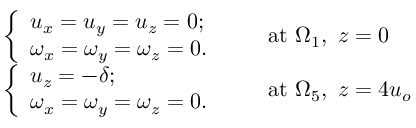<formula> <loc_0><loc_0><loc_500><loc_500>\begin{array} { r l } & { \left \{ \begin{array} { l l } { u _ { x } = u _ { y } = u _ { z } = 0 ; } \\ { \omega _ { x } = \omega _ { y } = \omega _ { z } = 0 . } \end{array} \quad a t \Omega _ { 1 } , z = 0 } \\ & { \left \{ \begin{array} { l l } { u _ { z } = - \delta ; } \\ { \omega _ { x } = \omega _ { y } = \omega _ { z } = 0 . } \end{array} \quad a t \Omega _ { 5 } , z = 4 u _ { o } } \end{array}</formula> 